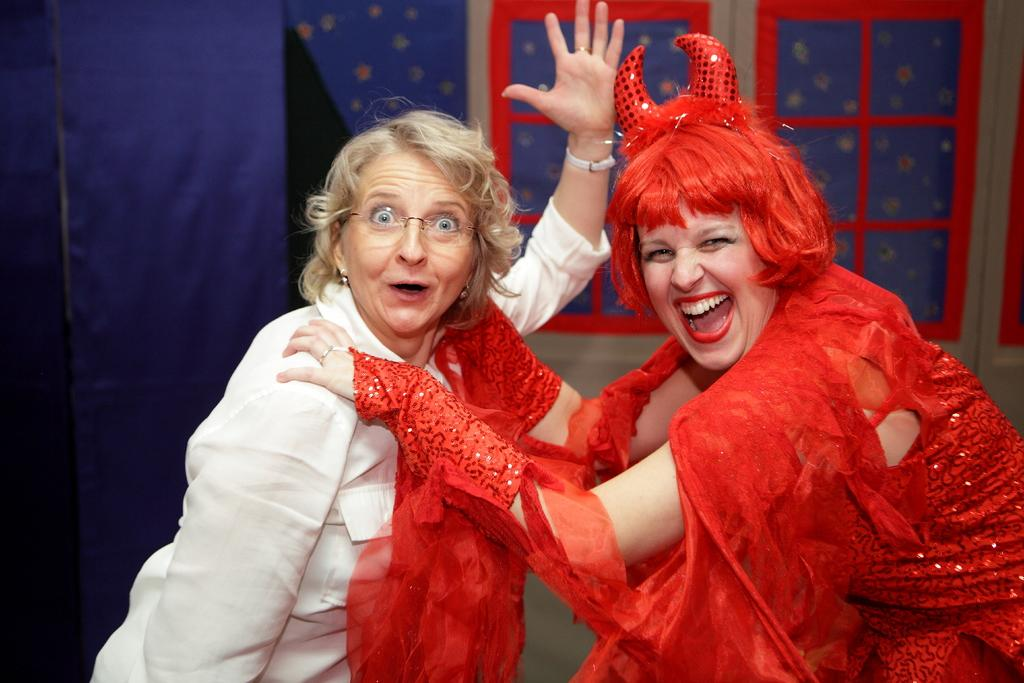How many people are present in the image? There are two people in the image. Can you describe the appearance of one of the people? One person is wearing a different costume. What can be seen in the background of the image? There is a curtain and windows in the background of the image. What type of secretary can be seen working in the building in the image? There is no secretary or building present in the image. Can you describe the tongue of the person wearing the different costume in the image? There is no information about the tongue of the person wearing the different costume in the image. 